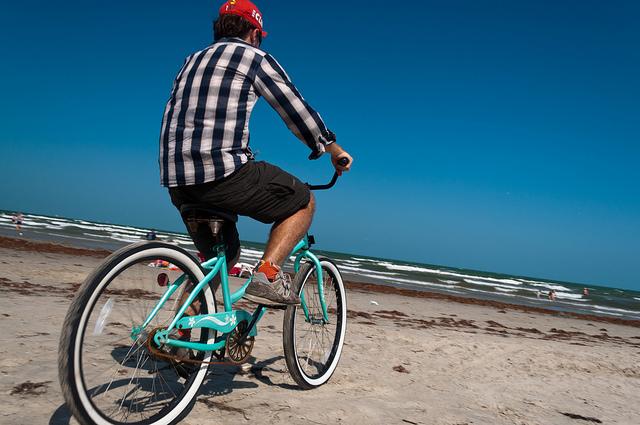Do the colors of the bike pop in this beach scene?
Write a very short answer. Yes. Do these guys need shoes where they're going?
Quick response, please. No. Where is the man riding his bike?
Concise answer only. Beach. Is the man wearing a helmet?
Write a very short answer. No. What is the person holding?
Be succinct. Handlebars. 